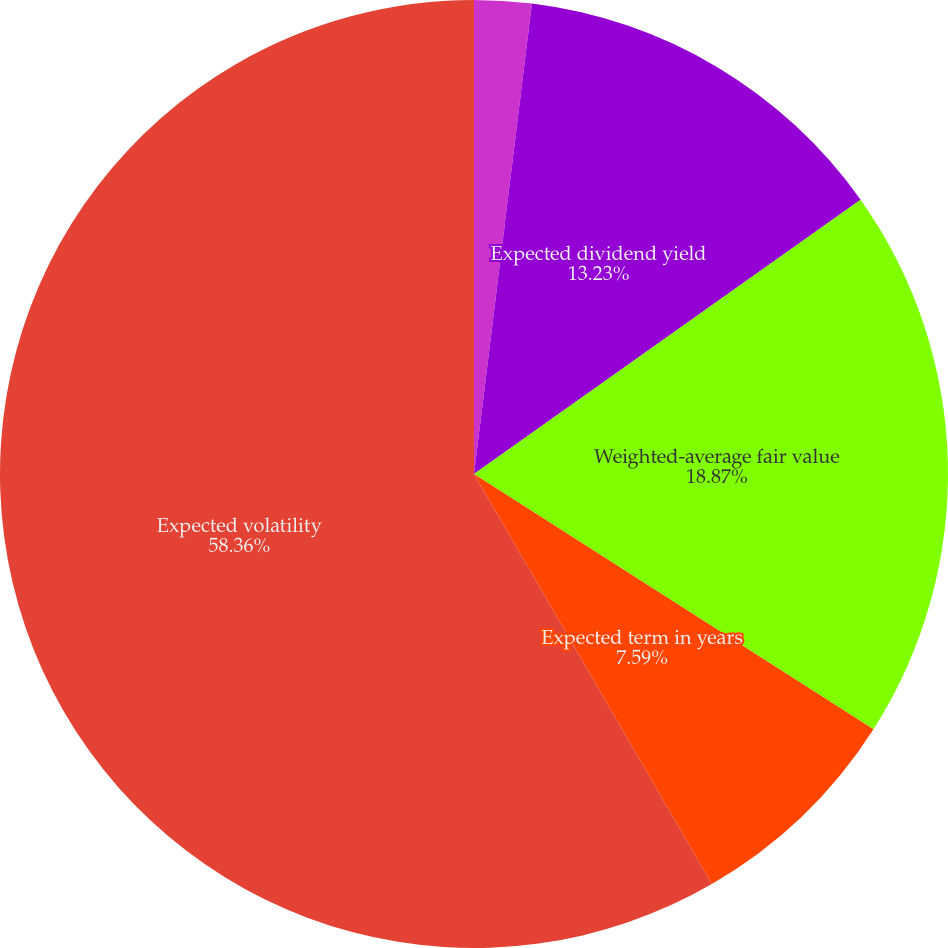Convert chart to OTSL. <chart><loc_0><loc_0><loc_500><loc_500><pie_chart><fcel>Risk-free interest rate<fcel>Expected dividend yield<fcel>Weighted-average fair value<fcel>Expected term in years<fcel>Expected volatility<nl><fcel>1.95%<fcel>13.23%<fcel>18.87%<fcel>7.59%<fcel>58.37%<nl></chart> 